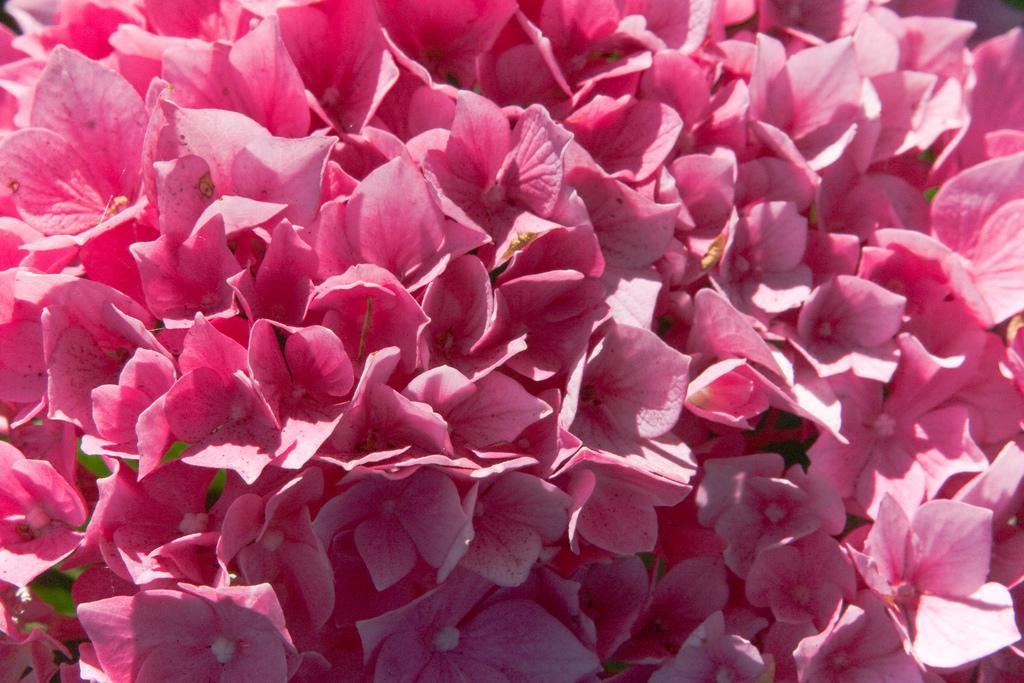In one or two sentences, can you explain what this image depicts? In the center of the image we can see a blossom. 